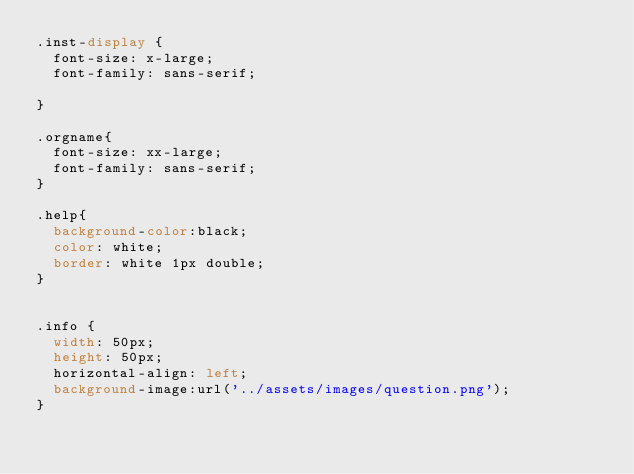<code> <loc_0><loc_0><loc_500><loc_500><_CSS_>.inst-display {
  font-size: x-large;
  font-family: sans-serif;

}

.orgname{
  font-size: xx-large;
  font-family: sans-serif;
}

.help{
  background-color:black;
  color: white;
  border: white 1px double;
}


.info {
  width: 50px;
  height: 50px;
  horizontal-align: left;
  background-image:url('../assets/images/question.png');
}
</code> 